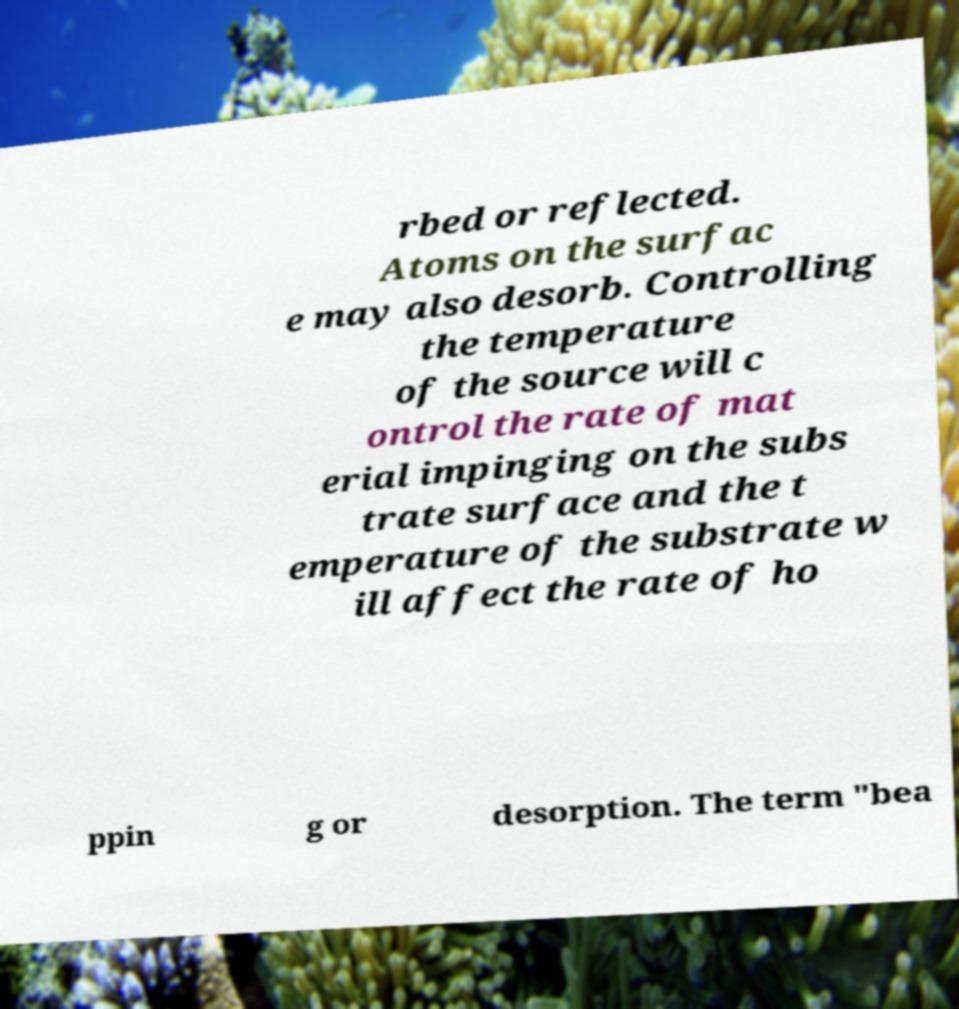Please identify and transcribe the text found in this image. rbed or reflected. Atoms on the surfac e may also desorb. Controlling the temperature of the source will c ontrol the rate of mat erial impinging on the subs trate surface and the t emperature of the substrate w ill affect the rate of ho ppin g or desorption. The term "bea 